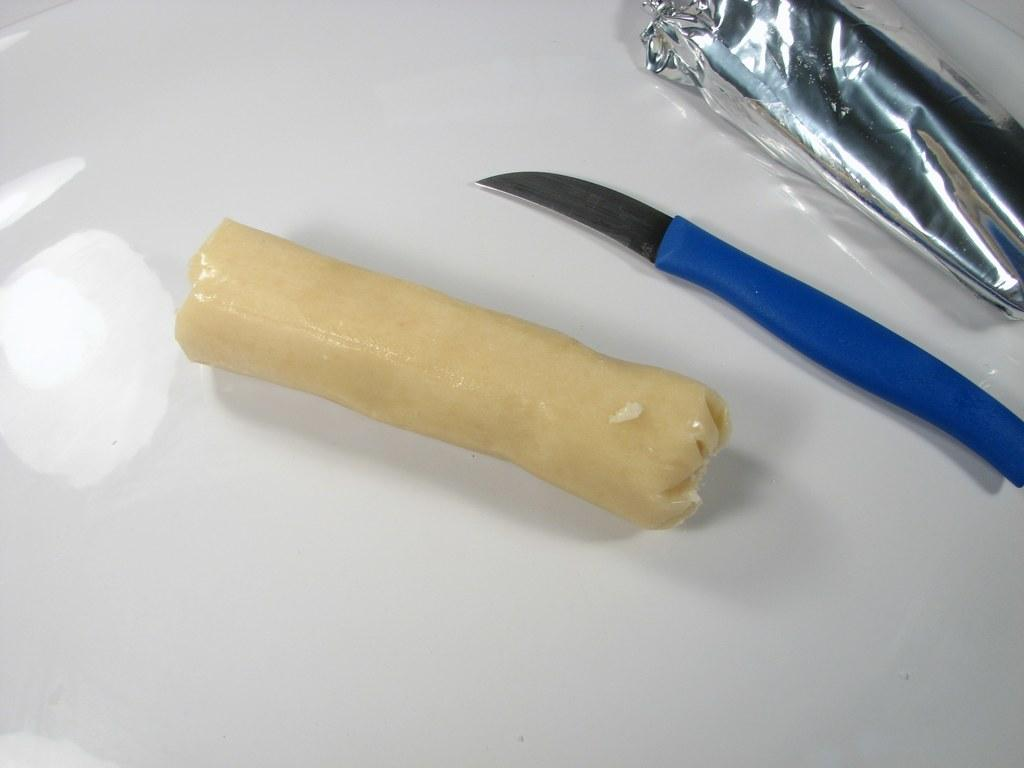What is the main object in the image? There is an object in the image, but its specific nature is not mentioned in the facts. What tool is visible in the image? There is a knife in the image. Is there any protective covering in the image? Yes, there is a cover in the image. What is the color of the surface on which the objects are placed? The objects are placed on a white surface. What shape does the feeling of shame take in the image? There is no mention of any emotions, including shame, in the image. The image only contains objects, such as an object, a knife, and a cover, placed on a white surface. 